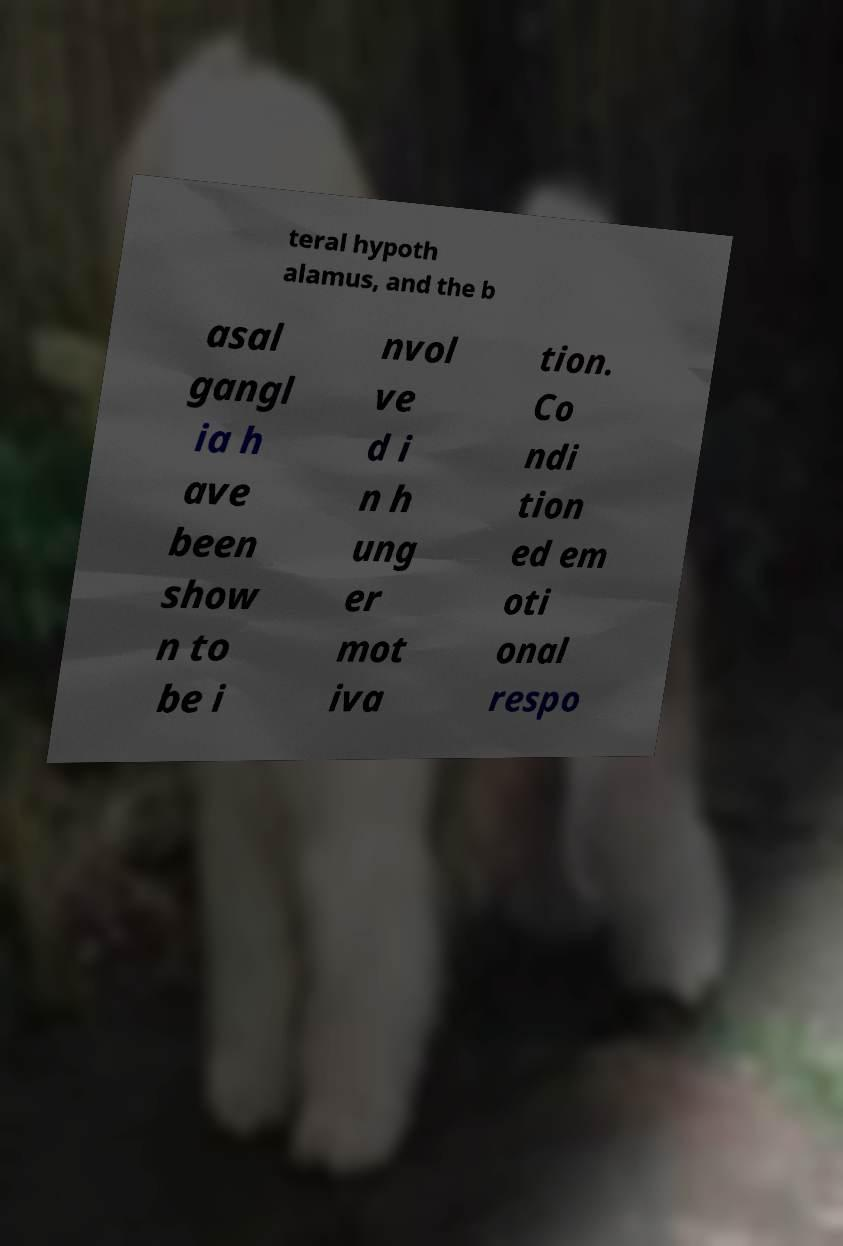I need the written content from this picture converted into text. Can you do that? teral hypoth alamus, and the b asal gangl ia h ave been show n to be i nvol ve d i n h ung er mot iva tion. Co ndi tion ed em oti onal respo 